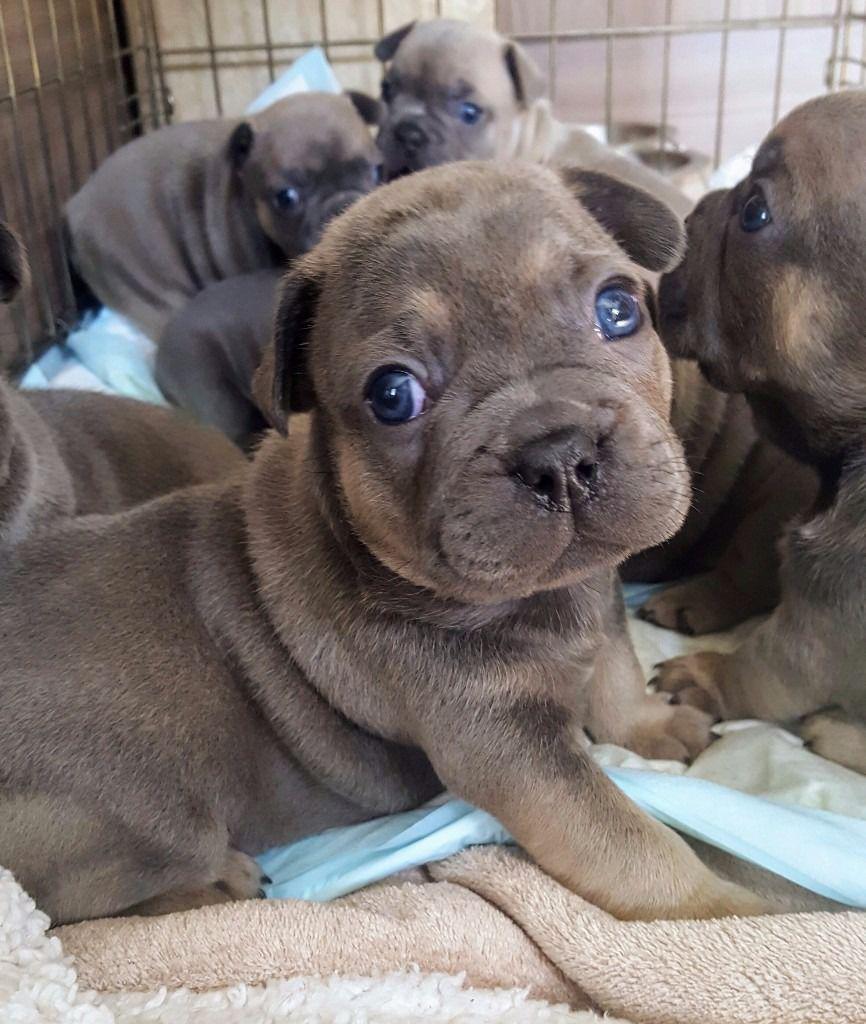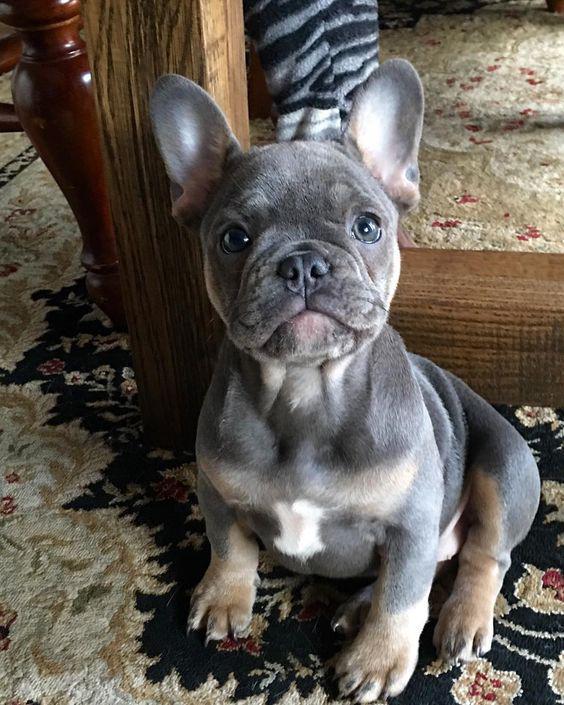The first image is the image on the left, the second image is the image on the right. Assess this claim about the two images: "The left image contains exactly two dogs.". Correct or not? Answer yes or no. No. The first image is the image on the left, the second image is the image on the right. Assess this claim about the two images: "Each image contains exactly two bulldogs, and the two dogs on the left are the same color, while the right image features a dark dog next to a lighter one.". Correct or not? Answer yes or no. No. 